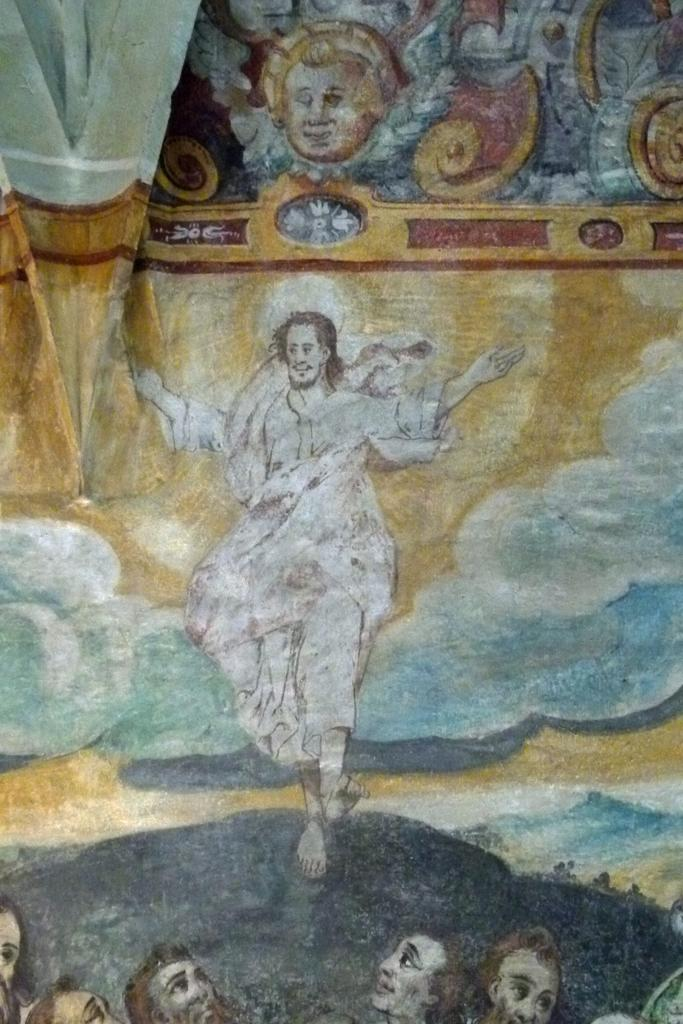What type of artwork is depicted in the image? The image is a painting. What is the main subject of the painting? There is a person standing on a rock in the painting. Are there any other people in the painting? Yes, there are other persons in front of the person on the rock in the painting. What type of net is being used by the person on the rock in the image? There is no net present in the image; the person is simply standing on a rock. 